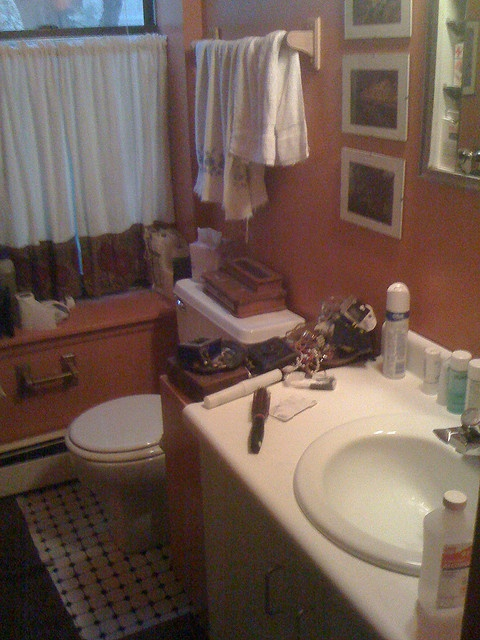Describe the objects in this image and their specific colors. I can see sink in lightblue, tan, and gray tones, toilet in lightblue, black, gray, maroon, and brown tones, bottle in lightblue, gray, and olive tones, bottle in lightblue, gray, and darkgray tones, and bottle in lightblue, gray, tan, and darkgray tones in this image. 